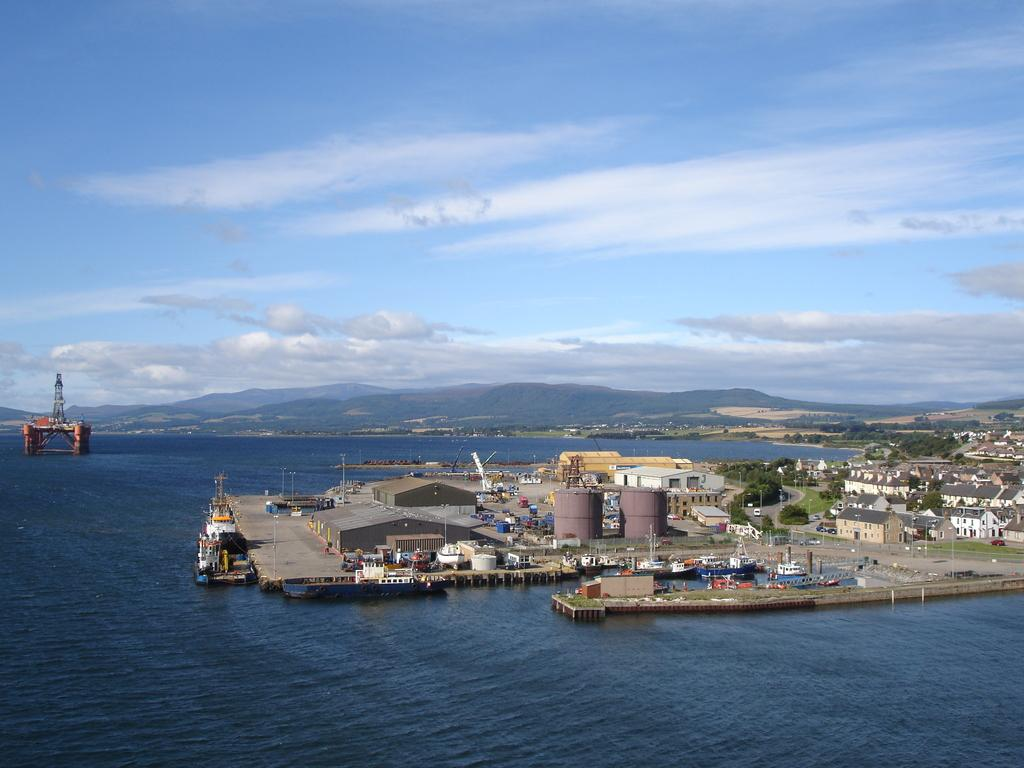What type of structures can be seen in the image? There are buildings and sheds in the image. What other objects are present in the image? There are tanks, a ship, and an object in the ocean. What can be seen in the sky in the image? The sky is visible in the image. What natural features are present in the image? There are mountains and trees in the image. Can you tell me how many pens are floating in the ocean in the image? There are no pens present in the image; it features an object in the ocean, but no pens are visible. Is there a bath visible in the image? There is no bath present in the image. 